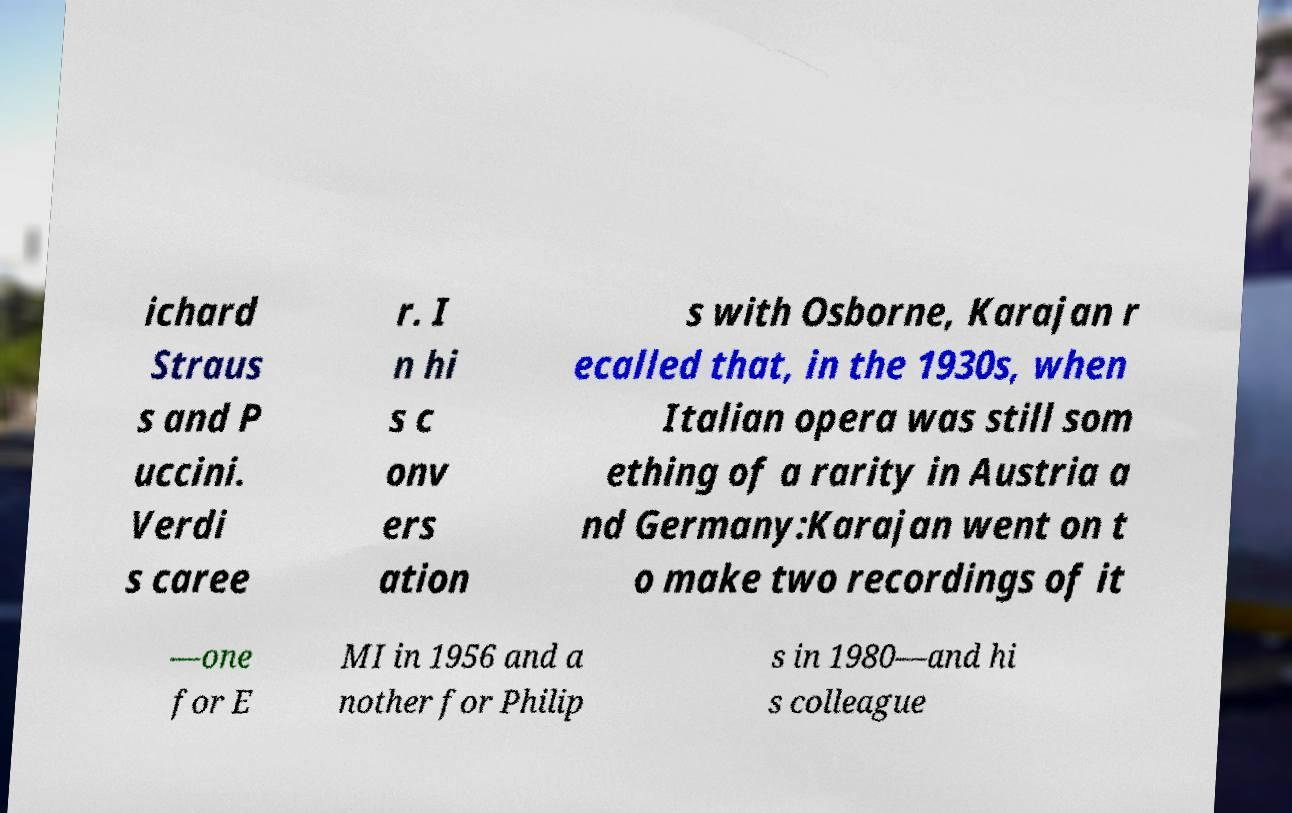Could you assist in decoding the text presented in this image and type it out clearly? ichard Straus s and P uccini. Verdi s caree r. I n hi s c onv ers ation s with Osborne, Karajan r ecalled that, in the 1930s, when Italian opera was still som ething of a rarity in Austria a nd Germany:Karajan went on t o make two recordings of it —one for E MI in 1956 and a nother for Philip s in 1980—and hi s colleague 